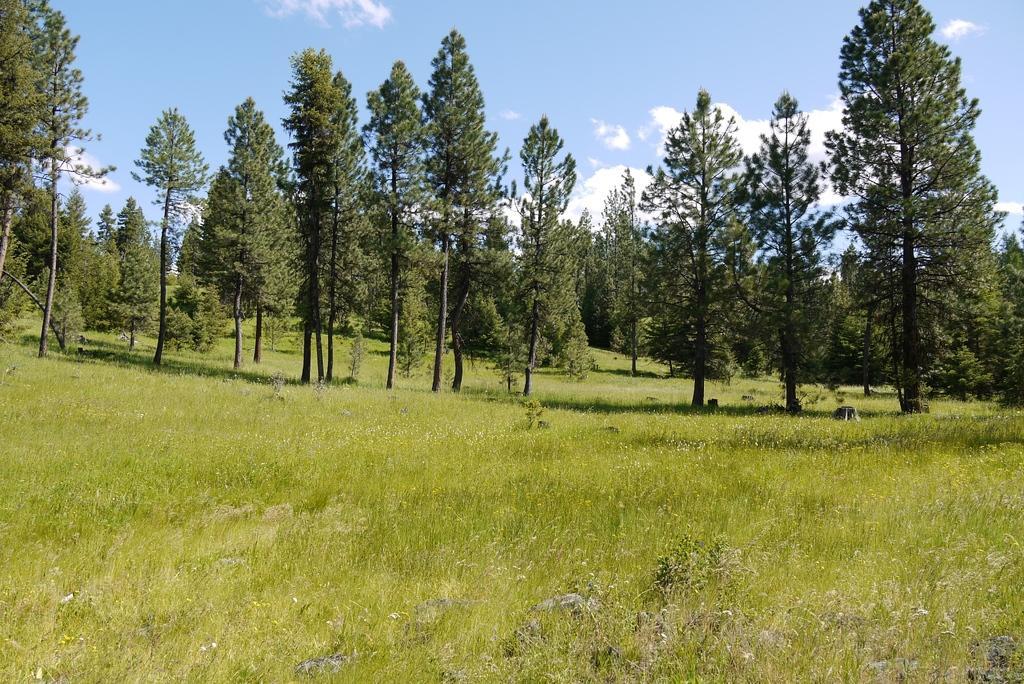In one or two sentences, can you explain what this image depicts? In this image we can see trees, grass,stones and sky with clouds in the background. 